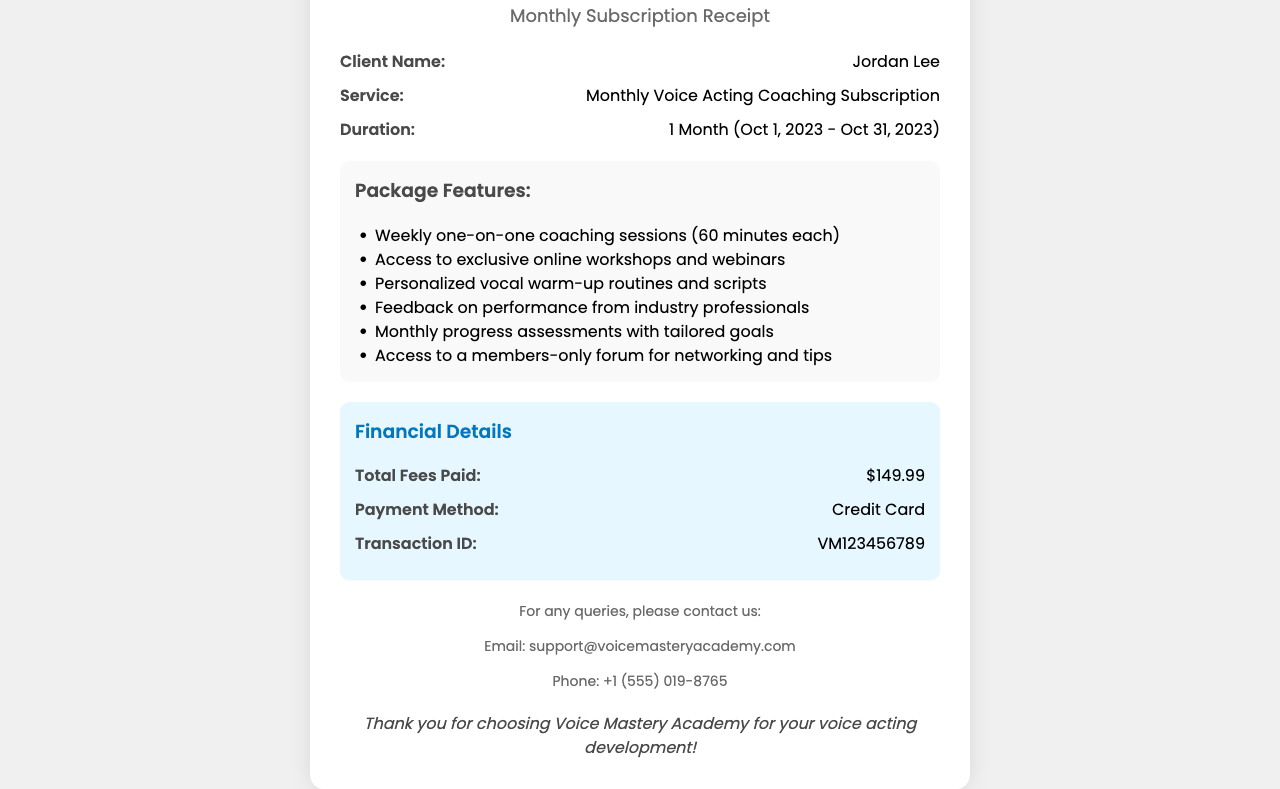What is the name of the client? The client's name is indicated in the details section of the receipt.
Answer: Jordan Lee What is the service provided? The service is stated clearly in the receipt under the service category.
Answer: Monthly Voice Acting Coaching Subscription What is the duration of the subscription? The duration is mentioned along with the specific dates in the details section.
Answer: 1 Month (Oct 1, 2023 - Oct 31, 2023) What is the total fee paid? The total fees paid are specified in the financial details section.
Answer: $149.99 How many coaching sessions are included per week? The number of coaching sessions is mentioned in the package features section.
Answer: Weekly one-on-one coaching sessions (60 minutes each) What kind of professionals provide feedback? The document mentions the source of feedback in the package features.
Answer: Industry professionals What payment method was used? The payment method is specified in the financial details section.
Answer: Credit Card What is the transaction ID? The unique transaction ID is provided in the financial details section.
Answer: VM123456789 What is included in the package aside from coaching sessions? The package features list includes various items, one being access to exclusive online workshops and webinars.
Answer: Access to exclusive online workshops and webinars 